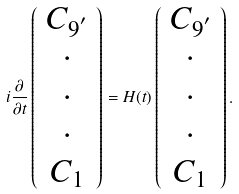<formula> <loc_0><loc_0><loc_500><loc_500>i \frac { \partial } { \partial t } \left ( \begin{array} { c c c } C _ { 9 ^ { ^ { \prime } } } \\ \cdot \\ \cdot \\ \cdot \\ C _ { 1 } \end{array} \right ) = H ( t ) \left ( \begin{array} { c c c } C _ { 9 ^ { ^ { \prime } } } \\ \cdot \\ \cdot \\ \cdot \\ C _ { 1 } \end{array} \right ) .</formula> 